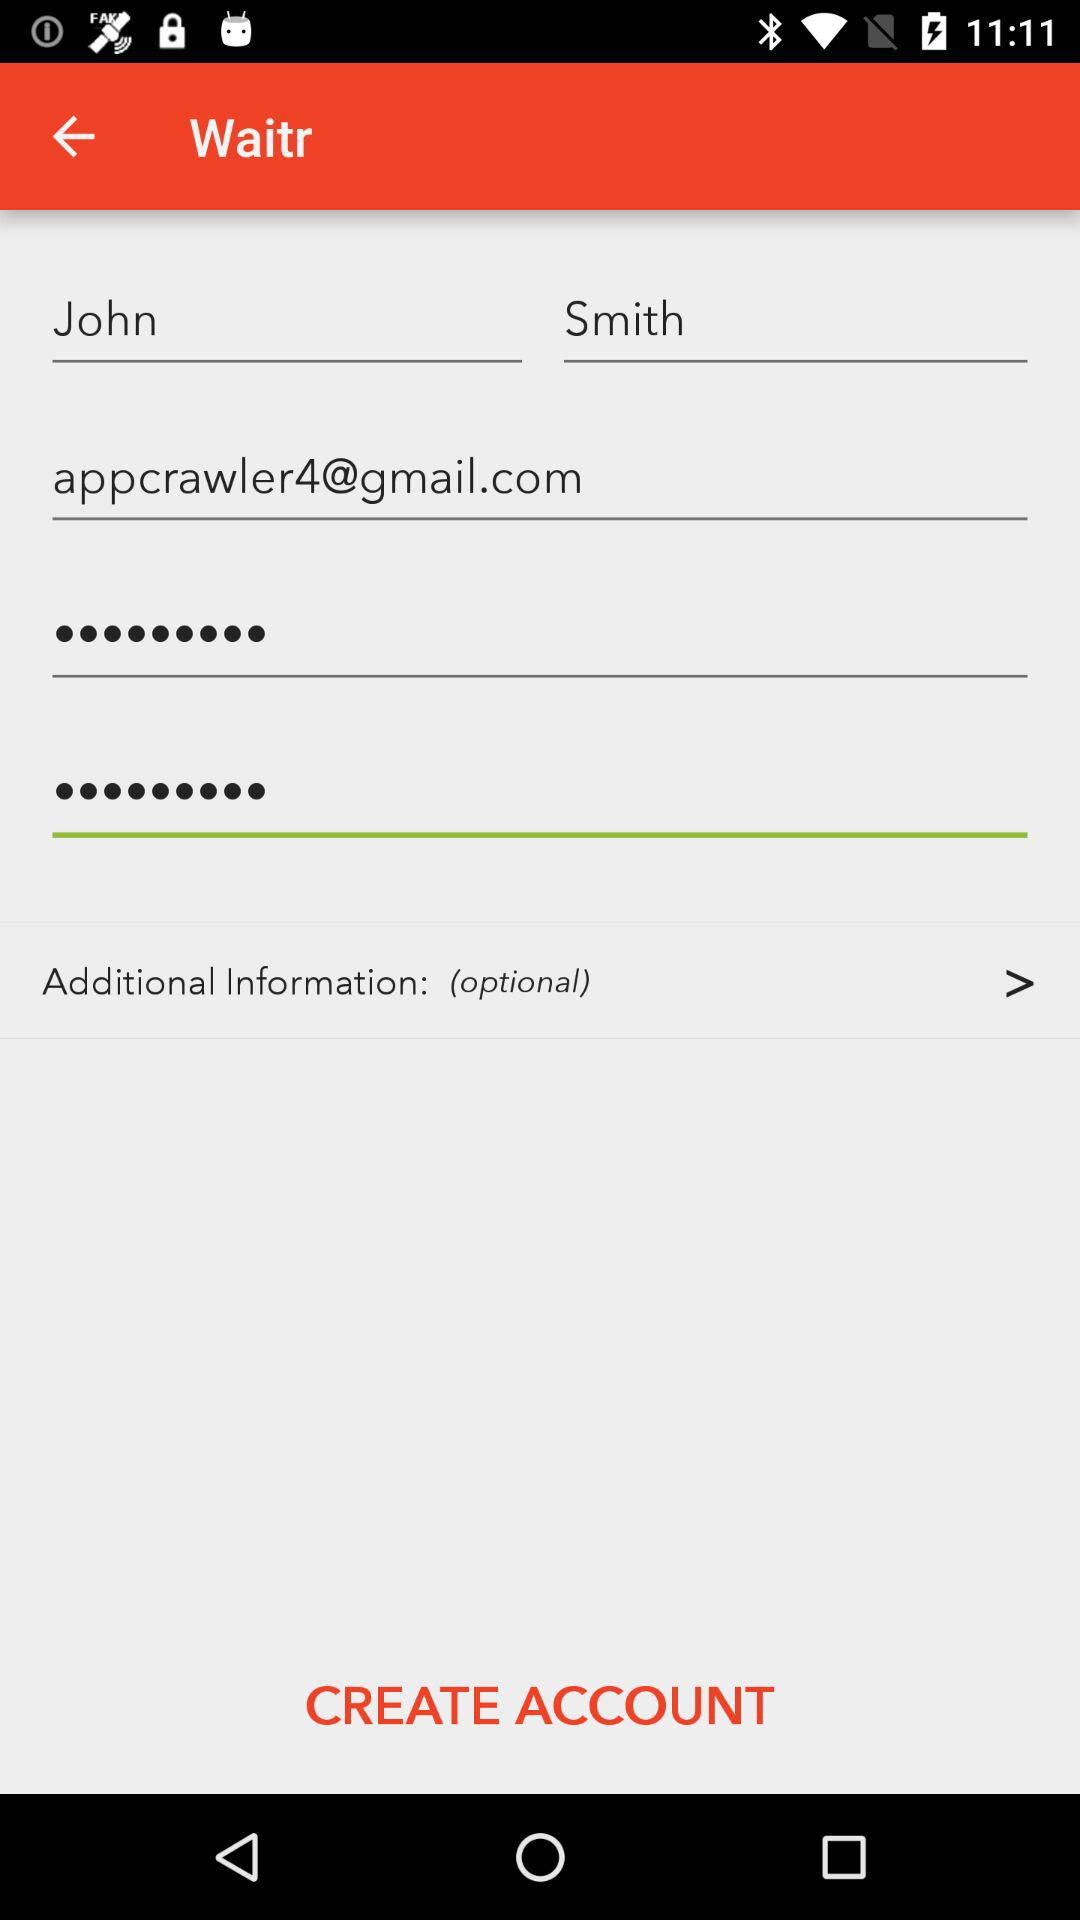What is the name of the application? The name of the application is "Waitr". 